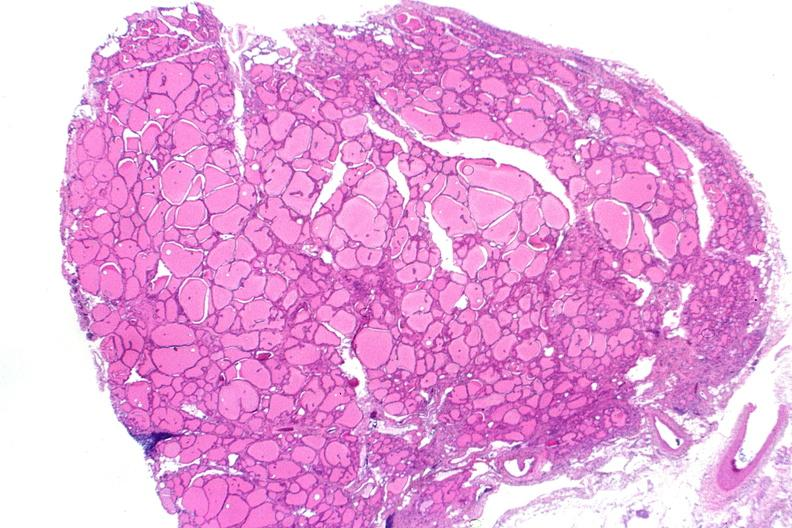does this image show thyroid, normal?
Answer the question using a single word or phrase. Yes 